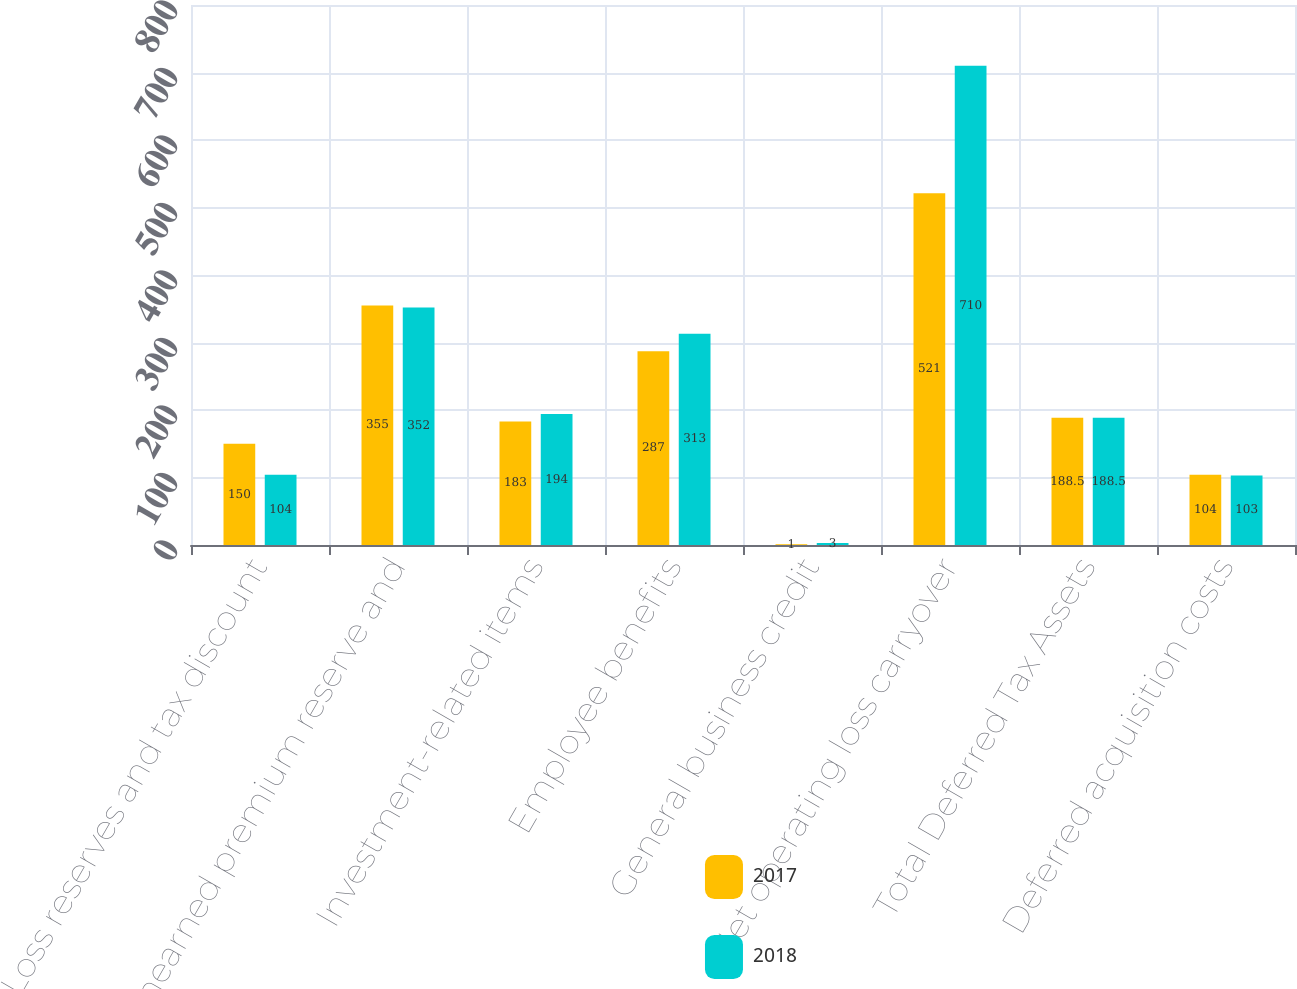<chart> <loc_0><loc_0><loc_500><loc_500><stacked_bar_chart><ecel><fcel>Loss reserves and tax discount<fcel>Unearned premium reserve and<fcel>Investment-related items<fcel>Employee benefits<fcel>General business credit<fcel>Net operating loss carryover<fcel>Total Deferred Tax Assets<fcel>Deferred acquisition costs<nl><fcel>2017<fcel>150<fcel>355<fcel>183<fcel>287<fcel>1<fcel>521<fcel>188.5<fcel>104<nl><fcel>2018<fcel>104<fcel>352<fcel>194<fcel>313<fcel>3<fcel>710<fcel>188.5<fcel>103<nl></chart> 